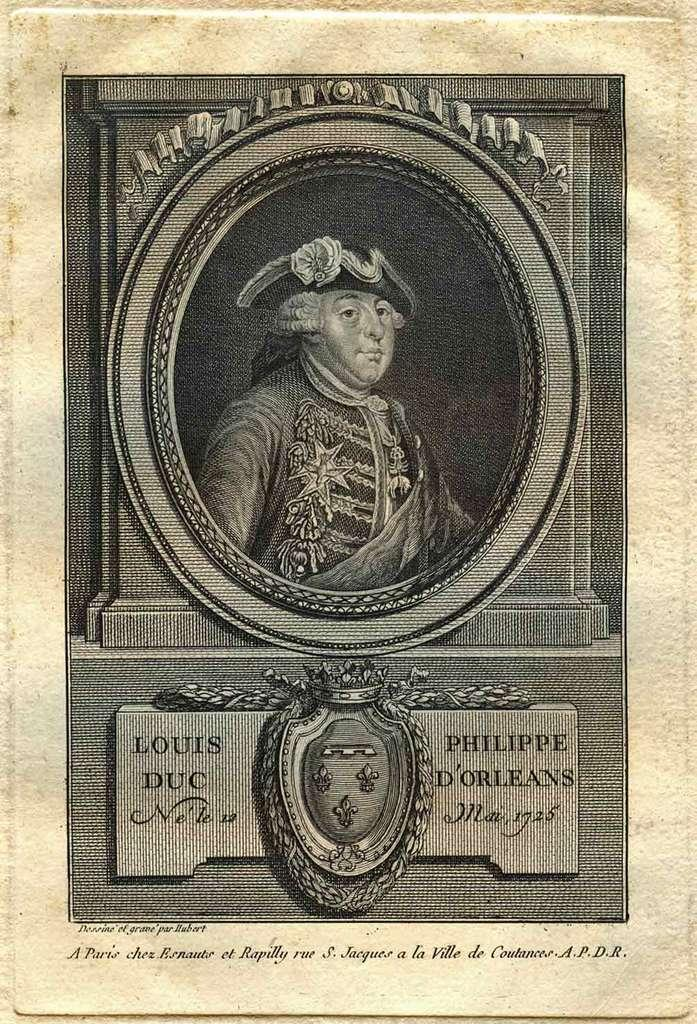What is featured in the image? There is a poster in the image. What can be seen on the poster? The poster contains a person wearing a cap. Are there any additional elements on the poster? Yes, there is text and a symbol at the bottom of the image. What type of ship is depicted in the image? There is no ship present in the image; it features a poster with a person wearing a cap and text and a symbol at the bottom. 